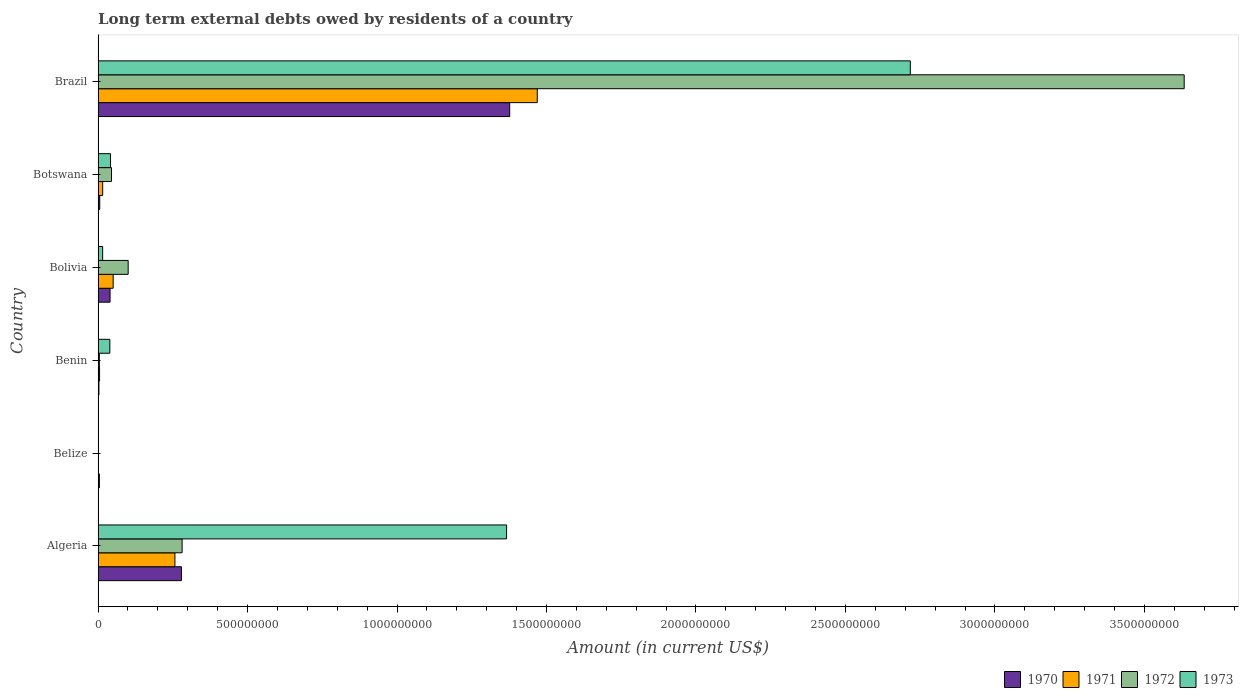Are the number of bars per tick equal to the number of legend labels?
Provide a short and direct response. No. How many bars are there on the 1st tick from the top?
Offer a terse response. 4. How many bars are there on the 3rd tick from the bottom?
Your answer should be very brief. 4. What is the label of the 2nd group of bars from the top?
Keep it short and to the point. Botswana. What is the amount of long-term external debts owed by residents in 1973 in Algeria?
Your response must be concise. 1.37e+09. Across all countries, what is the maximum amount of long-term external debts owed by residents in 1973?
Your answer should be very brief. 2.72e+09. Across all countries, what is the minimum amount of long-term external debts owed by residents in 1970?
Your answer should be very brief. 2.87e+06. What is the total amount of long-term external debts owed by residents in 1971 in the graph?
Provide a succinct answer. 1.80e+09. What is the difference between the amount of long-term external debts owed by residents in 1970 in Algeria and that in Benin?
Give a very brief answer. 2.76e+08. What is the difference between the amount of long-term external debts owed by residents in 1972 in Brazil and the amount of long-term external debts owed by residents in 1971 in Belize?
Your response must be concise. 3.63e+09. What is the average amount of long-term external debts owed by residents in 1972 per country?
Provide a short and direct response. 6.77e+08. What is the difference between the amount of long-term external debts owed by residents in 1972 and amount of long-term external debts owed by residents in 1973 in Botswana?
Offer a very short reply. 3.47e+06. In how many countries, is the amount of long-term external debts owed by residents in 1971 greater than 1600000000 US$?
Provide a short and direct response. 0. What is the ratio of the amount of long-term external debts owed by residents in 1970 in Botswana to that in Brazil?
Your answer should be very brief. 0. What is the difference between the highest and the second highest amount of long-term external debts owed by residents in 1973?
Keep it short and to the point. 1.35e+09. What is the difference between the highest and the lowest amount of long-term external debts owed by residents in 1973?
Give a very brief answer. 2.72e+09. In how many countries, is the amount of long-term external debts owed by residents in 1972 greater than the average amount of long-term external debts owed by residents in 1972 taken over all countries?
Give a very brief answer. 1. Is it the case that in every country, the sum of the amount of long-term external debts owed by residents in 1971 and amount of long-term external debts owed by residents in 1973 is greater than the sum of amount of long-term external debts owed by residents in 1972 and amount of long-term external debts owed by residents in 1970?
Provide a succinct answer. No. What is the difference between two consecutive major ticks on the X-axis?
Your answer should be very brief. 5.00e+08. Are the values on the major ticks of X-axis written in scientific E-notation?
Offer a very short reply. No. Does the graph contain any zero values?
Your response must be concise. Yes. Where does the legend appear in the graph?
Provide a short and direct response. Bottom right. How many legend labels are there?
Your answer should be very brief. 4. How are the legend labels stacked?
Your answer should be very brief. Horizontal. What is the title of the graph?
Ensure brevity in your answer.  Long term external debts owed by residents of a country. Does "1987" appear as one of the legend labels in the graph?
Your answer should be very brief. No. What is the label or title of the X-axis?
Give a very brief answer. Amount (in current US$). What is the label or title of the Y-axis?
Your answer should be very brief. Country. What is the Amount (in current US$) of 1970 in Algeria?
Offer a very short reply. 2.79e+08. What is the Amount (in current US$) of 1971 in Algeria?
Keep it short and to the point. 2.57e+08. What is the Amount (in current US$) in 1972 in Algeria?
Your answer should be compact. 2.81e+08. What is the Amount (in current US$) of 1973 in Algeria?
Your response must be concise. 1.37e+09. What is the Amount (in current US$) in 1970 in Belize?
Keep it short and to the point. 4.30e+06. What is the Amount (in current US$) in 1973 in Belize?
Offer a terse response. 0. What is the Amount (in current US$) in 1970 in Benin?
Your answer should be compact. 2.87e+06. What is the Amount (in current US$) of 1971 in Benin?
Provide a short and direct response. 4.99e+06. What is the Amount (in current US$) of 1972 in Benin?
Keep it short and to the point. 4.28e+06. What is the Amount (in current US$) of 1973 in Benin?
Ensure brevity in your answer.  3.93e+07. What is the Amount (in current US$) of 1970 in Bolivia?
Provide a short and direct response. 4.01e+07. What is the Amount (in current US$) of 1971 in Bolivia?
Your response must be concise. 5.04e+07. What is the Amount (in current US$) in 1972 in Bolivia?
Keep it short and to the point. 1.01e+08. What is the Amount (in current US$) in 1973 in Bolivia?
Make the answer very short. 1.53e+07. What is the Amount (in current US$) of 1970 in Botswana?
Ensure brevity in your answer.  5.57e+06. What is the Amount (in current US$) in 1971 in Botswana?
Provide a short and direct response. 1.54e+07. What is the Amount (in current US$) in 1972 in Botswana?
Provide a succinct answer. 4.50e+07. What is the Amount (in current US$) of 1973 in Botswana?
Keep it short and to the point. 4.15e+07. What is the Amount (in current US$) of 1970 in Brazil?
Keep it short and to the point. 1.38e+09. What is the Amount (in current US$) in 1971 in Brazil?
Offer a very short reply. 1.47e+09. What is the Amount (in current US$) of 1972 in Brazil?
Keep it short and to the point. 3.63e+09. What is the Amount (in current US$) in 1973 in Brazil?
Ensure brevity in your answer.  2.72e+09. Across all countries, what is the maximum Amount (in current US$) of 1970?
Give a very brief answer. 1.38e+09. Across all countries, what is the maximum Amount (in current US$) of 1971?
Give a very brief answer. 1.47e+09. Across all countries, what is the maximum Amount (in current US$) in 1972?
Keep it short and to the point. 3.63e+09. Across all countries, what is the maximum Amount (in current US$) in 1973?
Give a very brief answer. 2.72e+09. Across all countries, what is the minimum Amount (in current US$) in 1970?
Your answer should be compact. 2.87e+06. Across all countries, what is the minimum Amount (in current US$) in 1972?
Your answer should be compact. 0. What is the total Amount (in current US$) in 1970 in the graph?
Provide a short and direct response. 1.71e+09. What is the total Amount (in current US$) in 1971 in the graph?
Provide a succinct answer. 1.80e+09. What is the total Amount (in current US$) of 1972 in the graph?
Your answer should be very brief. 4.06e+09. What is the total Amount (in current US$) of 1973 in the graph?
Provide a short and direct response. 4.18e+09. What is the difference between the Amount (in current US$) of 1970 in Algeria and that in Belize?
Your answer should be very brief. 2.74e+08. What is the difference between the Amount (in current US$) of 1970 in Algeria and that in Benin?
Provide a short and direct response. 2.76e+08. What is the difference between the Amount (in current US$) in 1971 in Algeria and that in Benin?
Ensure brevity in your answer.  2.52e+08. What is the difference between the Amount (in current US$) in 1972 in Algeria and that in Benin?
Offer a very short reply. 2.77e+08. What is the difference between the Amount (in current US$) of 1973 in Algeria and that in Benin?
Make the answer very short. 1.33e+09. What is the difference between the Amount (in current US$) in 1970 in Algeria and that in Bolivia?
Your answer should be compact. 2.39e+08. What is the difference between the Amount (in current US$) of 1971 in Algeria and that in Bolivia?
Make the answer very short. 2.07e+08. What is the difference between the Amount (in current US$) in 1972 in Algeria and that in Bolivia?
Offer a terse response. 1.80e+08. What is the difference between the Amount (in current US$) of 1973 in Algeria and that in Bolivia?
Give a very brief answer. 1.35e+09. What is the difference between the Amount (in current US$) of 1970 in Algeria and that in Botswana?
Your response must be concise. 2.73e+08. What is the difference between the Amount (in current US$) of 1971 in Algeria and that in Botswana?
Your answer should be very brief. 2.42e+08. What is the difference between the Amount (in current US$) of 1972 in Algeria and that in Botswana?
Ensure brevity in your answer.  2.36e+08. What is the difference between the Amount (in current US$) of 1973 in Algeria and that in Botswana?
Give a very brief answer. 1.32e+09. What is the difference between the Amount (in current US$) in 1970 in Algeria and that in Brazil?
Provide a short and direct response. -1.10e+09. What is the difference between the Amount (in current US$) of 1971 in Algeria and that in Brazil?
Keep it short and to the point. -1.21e+09. What is the difference between the Amount (in current US$) in 1972 in Algeria and that in Brazil?
Offer a very short reply. -3.35e+09. What is the difference between the Amount (in current US$) of 1973 in Algeria and that in Brazil?
Keep it short and to the point. -1.35e+09. What is the difference between the Amount (in current US$) of 1970 in Belize and that in Benin?
Your response must be concise. 1.43e+06. What is the difference between the Amount (in current US$) in 1970 in Belize and that in Bolivia?
Your answer should be very brief. -3.58e+07. What is the difference between the Amount (in current US$) of 1970 in Belize and that in Botswana?
Provide a short and direct response. -1.27e+06. What is the difference between the Amount (in current US$) of 1970 in Belize and that in Brazil?
Your answer should be very brief. -1.37e+09. What is the difference between the Amount (in current US$) in 1970 in Benin and that in Bolivia?
Your answer should be very brief. -3.72e+07. What is the difference between the Amount (in current US$) in 1971 in Benin and that in Bolivia?
Offer a terse response. -4.54e+07. What is the difference between the Amount (in current US$) in 1972 in Benin and that in Bolivia?
Make the answer very short. -9.64e+07. What is the difference between the Amount (in current US$) in 1973 in Benin and that in Bolivia?
Your answer should be very brief. 2.40e+07. What is the difference between the Amount (in current US$) in 1970 in Benin and that in Botswana?
Your answer should be very brief. -2.70e+06. What is the difference between the Amount (in current US$) in 1971 in Benin and that in Botswana?
Provide a short and direct response. -1.04e+07. What is the difference between the Amount (in current US$) in 1972 in Benin and that in Botswana?
Your response must be concise. -4.07e+07. What is the difference between the Amount (in current US$) in 1973 in Benin and that in Botswana?
Ensure brevity in your answer.  -2.15e+06. What is the difference between the Amount (in current US$) in 1970 in Benin and that in Brazil?
Your answer should be compact. -1.37e+09. What is the difference between the Amount (in current US$) of 1971 in Benin and that in Brazil?
Provide a short and direct response. -1.46e+09. What is the difference between the Amount (in current US$) of 1972 in Benin and that in Brazil?
Your answer should be very brief. -3.63e+09. What is the difference between the Amount (in current US$) in 1973 in Benin and that in Brazil?
Your response must be concise. -2.68e+09. What is the difference between the Amount (in current US$) of 1970 in Bolivia and that in Botswana?
Make the answer very short. 3.45e+07. What is the difference between the Amount (in current US$) of 1971 in Bolivia and that in Botswana?
Your response must be concise. 3.50e+07. What is the difference between the Amount (in current US$) in 1972 in Bolivia and that in Botswana?
Ensure brevity in your answer.  5.57e+07. What is the difference between the Amount (in current US$) in 1973 in Bolivia and that in Botswana?
Provide a succinct answer. -2.62e+07. What is the difference between the Amount (in current US$) of 1970 in Bolivia and that in Brazil?
Make the answer very short. -1.34e+09. What is the difference between the Amount (in current US$) of 1971 in Bolivia and that in Brazil?
Offer a terse response. -1.42e+09. What is the difference between the Amount (in current US$) in 1972 in Bolivia and that in Brazil?
Give a very brief answer. -3.53e+09. What is the difference between the Amount (in current US$) of 1973 in Bolivia and that in Brazil?
Your answer should be compact. -2.70e+09. What is the difference between the Amount (in current US$) of 1970 in Botswana and that in Brazil?
Give a very brief answer. -1.37e+09. What is the difference between the Amount (in current US$) of 1971 in Botswana and that in Brazil?
Provide a short and direct response. -1.45e+09. What is the difference between the Amount (in current US$) of 1972 in Botswana and that in Brazil?
Your response must be concise. -3.59e+09. What is the difference between the Amount (in current US$) of 1973 in Botswana and that in Brazil?
Provide a succinct answer. -2.68e+09. What is the difference between the Amount (in current US$) of 1970 in Algeria and the Amount (in current US$) of 1971 in Benin?
Keep it short and to the point. 2.74e+08. What is the difference between the Amount (in current US$) of 1970 in Algeria and the Amount (in current US$) of 1972 in Benin?
Provide a succinct answer. 2.75e+08. What is the difference between the Amount (in current US$) of 1970 in Algeria and the Amount (in current US$) of 1973 in Benin?
Ensure brevity in your answer.  2.39e+08. What is the difference between the Amount (in current US$) of 1971 in Algeria and the Amount (in current US$) of 1972 in Benin?
Offer a very short reply. 2.53e+08. What is the difference between the Amount (in current US$) of 1971 in Algeria and the Amount (in current US$) of 1973 in Benin?
Offer a very short reply. 2.18e+08. What is the difference between the Amount (in current US$) of 1972 in Algeria and the Amount (in current US$) of 1973 in Benin?
Give a very brief answer. 2.42e+08. What is the difference between the Amount (in current US$) in 1970 in Algeria and the Amount (in current US$) in 1971 in Bolivia?
Your response must be concise. 2.28e+08. What is the difference between the Amount (in current US$) in 1970 in Algeria and the Amount (in current US$) in 1972 in Bolivia?
Offer a very short reply. 1.78e+08. What is the difference between the Amount (in current US$) of 1970 in Algeria and the Amount (in current US$) of 1973 in Bolivia?
Provide a short and direct response. 2.63e+08. What is the difference between the Amount (in current US$) of 1971 in Algeria and the Amount (in current US$) of 1972 in Bolivia?
Offer a terse response. 1.56e+08. What is the difference between the Amount (in current US$) of 1971 in Algeria and the Amount (in current US$) of 1973 in Bolivia?
Offer a very short reply. 2.42e+08. What is the difference between the Amount (in current US$) of 1972 in Algeria and the Amount (in current US$) of 1973 in Bolivia?
Make the answer very short. 2.66e+08. What is the difference between the Amount (in current US$) of 1970 in Algeria and the Amount (in current US$) of 1971 in Botswana?
Provide a succinct answer. 2.63e+08. What is the difference between the Amount (in current US$) of 1970 in Algeria and the Amount (in current US$) of 1972 in Botswana?
Your response must be concise. 2.34e+08. What is the difference between the Amount (in current US$) in 1970 in Algeria and the Amount (in current US$) in 1973 in Botswana?
Your answer should be compact. 2.37e+08. What is the difference between the Amount (in current US$) in 1971 in Algeria and the Amount (in current US$) in 1972 in Botswana?
Ensure brevity in your answer.  2.12e+08. What is the difference between the Amount (in current US$) in 1971 in Algeria and the Amount (in current US$) in 1973 in Botswana?
Ensure brevity in your answer.  2.16e+08. What is the difference between the Amount (in current US$) in 1972 in Algeria and the Amount (in current US$) in 1973 in Botswana?
Offer a terse response. 2.40e+08. What is the difference between the Amount (in current US$) of 1970 in Algeria and the Amount (in current US$) of 1971 in Brazil?
Offer a very short reply. -1.19e+09. What is the difference between the Amount (in current US$) in 1970 in Algeria and the Amount (in current US$) in 1972 in Brazil?
Your response must be concise. -3.35e+09. What is the difference between the Amount (in current US$) of 1970 in Algeria and the Amount (in current US$) of 1973 in Brazil?
Offer a terse response. -2.44e+09. What is the difference between the Amount (in current US$) in 1971 in Algeria and the Amount (in current US$) in 1972 in Brazil?
Your answer should be compact. -3.38e+09. What is the difference between the Amount (in current US$) of 1971 in Algeria and the Amount (in current US$) of 1973 in Brazil?
Offer a very short reply. -2.46e+09. What is the difference between the Amount (in current US$) of 1972 in Algeria and the Amount (in current US$) of 1973 in Brazil?
Make the answer very short. -2.44e+09. What is the difference between the Amount (in current US$) in 1970 in Belize and the Amount (in current US$) in 1971 in Benin?
Provide a succinct answer. -6.88e+05. What is the difference between the Amount (in current US$) in 1970 in Belize and the Amount (in current US$) in 1972 in Benin?
Offer a very short reply. 2.40e+04. What is the difference between the Amount (in current US$) of 1970 in Belize and the Amount (in current US$) of 1973 in Benin?
Ensure brevity in your answer.  -3.50e+07. What is the difference between the Amount (in current US$) of 1970 in Belize and the Amount (in current US$) of 1971 in Bolivia?
Give a very brief answer. -4.61e+07. What is the difference between the Amount (in current US$) in 1970 in Belize and the Amount (in current US$) in 1972 in Bolivia?
Your response must be concise. -9.63e+07. What is the difference between the Amount (in current US$) of 1970 in Belize and the Amount (in current US$) of 1973 in Bolivia?
Your answer should be compact. -1.10e+07. What is the difference between the Amount (in current US$) of 1970 in Belize and the Amount (in current US$) of 1971 in Botswana?
Make the answer very short. -1.11e+07. What is the difference between the Amount (in current US$) of 1970 in Belize and the Amount (in current US$) of 1972 in Botswana?
Make the answer very short. -4.07e+07. What is the difference between the Amount (in current US$) of 1970 in Belize and the Amount (in current US$) of 1973 in Botswana?
Offer a terse response. -3.72e+07. What is the difference between the Amount (in current US$) of 1970 in Belize and the Amount (in current US$) of 1971 in Brazil?
Your answer should be compact. -1.46e+09. What is the difference between the Amount (in current US$) in 1970 in Belize and the Amount (in current US$) in 1972 in Brazil?
Offer a very short reply. -3.63e+09. What is the difference between the Amount (in current US$) of 1970 in Belize and the Amount (in current US$) of 1973 in Brazil?
Your answer should be compact. -2.71e+09. What is the difference between the Amount (in current US$) of 1970 in Benin and the Amount (in current US$) of 1971 in Bolivia?
Keep it short and to the point. -4.75e+07. What is the difference between the Amount (in current US$) in 1970 in Benin and the Amount (in current US$) in 1972 in Bolivia?
Provide a short and direct response. -9.78e+07. What is the difference between the Amount (in current US$) of 1970 in Benin and the Amount (in current US$) of 1973 in Bolivia?
Your answer should be very brief. -1.24e+07. What is the difference between the Amount (in current US$) of 1971 in Benin and the Amount (in current US$) of 1972 in Bolivia?
Your response must be concise. -9.57e+07. What is the difference between the Amount (in current US$) in 1971 in Benin and the Amount (in current US$) in 1973 in Bolivia?
Offer a very short reply. -1.03e+07. What is the difference between the Amount (in current US$) in 1972 in Benin and the Amount (in current US$) in 1973 in Bolivia?
Ensure brevity in your answer.  -1.10e+07. What is the difference between the Amount (in current US$) in 1970 in Benin and the Amount (in current US$) in 1971 in Botswana?
Make the answer very short. -1.25e+07. What is the difference between the Amount (in current US$) of 1970 in Benin and the Amount (in current US$) of 1972 in Botswana?
Your answer should be very brief. -4.21e+07. What is the difference between the Amount (in current US$) in 1970 in Benin and the Amount (in current US$) in 1973 in Botswana?
Provide a short and direct response. -3.86e+07. What is the difference between the Amount (in current US$) in 1971 in Benin and the Amount (in current US$) in 1972 in Botswana?
Your answer should be compact. -4.00e+07. What is the difference between the Amount (in current US$) in 1971 in Benin and the Amount (in current US$) in 1973 in Botswana?
Your answer should be compact. -3.65e+07. What is the difference between the Amount (in current US$) of 1972 in Benin and the Amount (in current US$) of 1973 in Botswana?
Offer a very short reply. -3.72e+07. What is the difference between the Amount (in current US$) in 1970 in Benin and the Amount (in current US$) in 1971 in Brazil?
Ensure brevity in your answer.  -1.47e+09. What is the difference between the Amount (in current US$) in 1970 in Benin and the Amount (in current US$) in 1972 in Brazil?
Your answer should be compact. -3.63e+09. What is the difference between the Amount (in current US$) in 1970 in Benin and the Amount (in current US$) in 1973 in Brazil?
Provide a succinct answer. -2.71e+09. What is the difference between the Amount (in current US$) of 1971 in Benin and the Amount (in current US$) of 1972 in Brazil?
Provide a succinct answer. -3.63e+09. What is the difference between the Amount (in current US$) in 1971 in Benin and the Amount (in current US$) in 1973 in Brazil?
Offer a very short reply. -2.71e+09. What is the difference between the Amount (in current US$) of 1972 in Benin and the Amount (in current US$) of 1973 in Brazil?
Provide a succinct answer. -2.71e+09. What is the difference between the Amount (in current US$) in 1970 in Bolivia and the Amount (in current US$) in 1971 in Botswana?
Offer a very short reply. 2.47e+07. What is the difference between the Amount (in current US$) of 1970 in Bolivia and the Amount (in current US$) of 1972 in Botswana?
Make the answer very short. -4.88e+06. What is the difference between the Amount (in current US$) in 1970 in Bolivia and the Amount (in current US$) in 1973 in Botswana?
Keep it short and to the point. -1.40e+06. What is the difference between the Amount (in current US$) in 1971 in Bolivia and the Amount (in current US$) in 1972 in Botswana?
Offer a very short reply. 5.46e+06. What is the difference between the Amount (in current US$) in 1971 in Bolivia and the Amount (in current US$) in 1973 in Botswana?
Provide a short and direct response. 8.94e+06. What is the difference between the Amount (in current US$) in 1972 in Bolivia and the Amount (in current US$) in 1973 in Botswana?
Provide a short and direct response. 5.92e+07. What is the difference between the Amount (in current US$) in 1970 in Bolivia and the Amount (in current US$) in 1971 in Brazil?
Provide a short and direct response. -1.43e+09. What is the difference between the Amount (in current US$) in 1970 in Bolivia and the Amount (in current US$) in 1972 in Brazil?
Your answer should be compact. -3.59e+09. What is the difference between the Amount (in current US$) in 1970 in Bolivia and the Amount (in current US$) in 1973 in Brazil?
Your answer should be very brief. -2.68e+09. What is the difference between the Amount (in current US$) in 1971 in Bolivia and the Amount (in current US$) in 1972 in Brazil?
Your response must be concise. -3.58e+09. What is the difference between the Amount (in current US$) of 1971 in Bolivia and the Amount (in current US$) of 1973 in Brazil?
Offer a very short reply. -2.67e+09. What is the difference between the Amount (in current US$) in 1972 in Bolivia and the Amount (in current US$) in 1973 in Brazil?
Give a very brief answer. -2.62e+09. What is the difference between the Amount (in current US$) in 1970 in Botswana and the Amount (in current US$) in 1971 in Brazil?
Offer a very short reply. -1.46e+09. What is the difference between the Amount (in current US$) in 1970 in Botswana and the Amount (in current US$) in 1972 in Brazil?
Offer a very short reply. -3.63e+09. What is the difference between the Amount (in current US$) of 1970 in Botswana and the Amount (in current US$) of 1973 in Brazil?
Provide a short and direct response. -2.71e+09. What is the difference between the Amount (in current US$) in 1971 in Botswana and the Amount (in current US$) in 1972 in Brazil?
Keep it short and to the point. -3.62e+09. What is the difference between the Amount (in current US$) of 1971 in Botswana and the Amount (in current US$) of 1973 in Brazil?
Make the answer very short. -2.70e+09. What is the difference between the Amount (in current US$) of 1972 in Botswana and the Amount (in current US$) of 1973 in Brazil?
Your answer should be compact. -2.67e+09. What is the average Amount (in current US$) in 1970 per country?
Give a very brief answer. 2.85e+08. What is the average Amount (in current US$) in 1971 per country?
Offer a very short reply. 2.99e+08. What is the average Amount (in current US$) of 1972 per country?
Your answer should be compact. 6.77e+08. What is the average Amount (in current US$) of 1973 per country?
Offer a very short reply. 6.97e+08. What is the difference between the Amount (in current US$) of 1970 and Amount (in current US$) of 1971 in Algeria?
Provide a succinct answer. 2.18e+07. What is the difference between the Amount (in current US$) in 1970 and Amount (in current US$) in 1972 in Algeria?
Your response must be concise. -2.27e+06. What is the difference between the Amount (in current US$) of 1970 and Amount (in current US$) of 1973 in Algeria?
Offer a very short reply. -1.09e+09. What is the difference between the Amount (in current US$) of 1971 and Amount (in current US$) of 1972 in Algeria?
Provide a short and direct response. -2.41e+07. What is the difference between the Amount (in current US$) in 1971 and Amount (in current US$) in 1973 in Algeria?
Provide a succinct answer. -1.11e+09. What is the difference between the Amount (in current US$) of 1972 and Amount (in current US$) of 1973 in Algeria?
Make the answer very short. -1.09e+09. What is the difference between the Amount (in current US$) of 1970 and Amount (in current US$) of 1971 in Benin?
Keep it short and to the point. -2.12e+06. What is the difference between the Amount (in current US$) of 1970 and Amount (in current US$) of 1972 in Benin?
Ensure brevity in your answer.  -1.41e+06. What is the difference between the Amount (in current US$) in 1970 and Amount (in current US$) in 1973 in Benin?
Offer a terse response. -3.65e+07. What is the difference between the Amount (in current US$) in 1971 and Amount (in current US$) in 1972 in Benin?
Ensure brevity in your answer.  7.12e+05. What is the difference between the Amount (in current US$) in 1971 and Amount (in current US$) in 1973 in Benin?
Provide a short and direct response. -3.43e+07. What is the difference between the Amount (in current US$) in 1972 and Amount (in current US$) in 1973 in Benin?
Provide a short and direct response. -3.51e+07. What is the difference between the Amount (in current US$) in 1970 and Amount (in current US$) in 1971 in Bolivia?
Offer a very short reply. -1.03e+07. What is the difference between the Amount (in current US$) of 1970 and Amount (in current US$) of 1972 in Bolivia?
Give a very brief answer. -6.06e+07. What is the difference between the Amount (in current US$) of 1970 and Amount (in current US$) of 1973 in Bolivia?
Offer a very short reply. 2.48e+07. What is the difference between the Amount (in current US$) in 1971 and Amount (in current US$) in 1972 in Bolivia?
Offer a terse response. -5.02e+07. What is the difference between the Amount (in current US$) in 1971 and Amount (in current US$) in 1973 in Bolivia?
Your answer should be very brief. 3.51e+07. What is the difference between the Amount (in current US$) of 1972 and Amount (in current US$) of 1973 in Bolivia?
Your answer should be very brief. 8.53e+07. What is the difference between the Amount (in current US$) of 1970 and Amount (in current US$) of 1971 in Botswana?
Ensure brevity in your answer.  -9.82e+06. What is the difference between the Amount (in current US$) of 1970 and Amount (in current US$) of 1972 in Botswana?
Give a very brief answer. -3.94e+07. What is the difference between the Amount (in current US$) of 1970 and Amount (in current US$) of 1973 in Botswana?
Ensure brevity in your answer.  -3.59e+07. What is the difference between the Amount (in current US$) of 1971 and Amount (in current US$) of 1972 in Botswana?
Give a very brief answer. -2.96e+07. What is the difference between the Amount (in current US$) of 1971 and Amount (in current US$) of 1973 in Botswana?
Your answer should be compact. -2.61e+07. What is the difference between the Amount (in current US$) of 1972 and Amount (in current US$) of 1973 in Botswana?
Provide a short and direct response. 3.47e+06. What is the difference between the Amount (in current US$) in 1970 and Amount (in current US$) in 1971 in Brazil?
Give a very brief answer. -9.22e+07. What is the difference between the Amount (in current US$) in 1970 and Amount (in current US$) in 1972 in Brazil?
Offer a very short reply. -2.26e+09. What is the difference between the Amount (in current US$) of 1970 and Amount (in current US$) of 1973 in Brazil?
Make the answer very short. -1.34e+09. What is the difference between the Amount (in current US$) in 1971 and Amount (in current US$) in 1972 in Brazil?
Offer a very short reply. -2.16e+09. What is the difference between the Amount (in current US$) of 1971 and Amount (in current US$) of 1973 in Brazil?
Your answer should be very brief. -1.25e+09. What is the difference between the Amount (in current US$) of 1972 and Amount (in current US$) of 1973 in Brazil?
Ensure brevity in your answer.  9.16e+08. What is the ratio of the Amount (in current US$) of 1970 in Algeria to that in Belize?
Your response must be concise. 64.82. What is the ratio of the Amount (in current US$) in 1970 in Algeria to that in Benin?
Provide a short and direct response. 97.24. What is the ratio of the Amount (in current US$) of 1971 in Algeria to that in Benin?
Your answer should be very brief. 51.51. What is the ratio of the Amount (in current US$) in 1972 in Algeria to that in Benin?
Keep it short and to the point. 65.71. What is the ratio of the Amount (in current US$) in 1973 in Algeria to that in Benin?
Give a very brief answer. 34.74. What is the ratio of the Amount (in current US$) of 1970 in Algeria to that in Bolivia?
Your answer should be very brief. 6.96. What is the ratio of the Amount (in current US$) of 1971 in Algeria to that in Bolivia?
Your answer should be very brief. 5.1. What is the ratio of the Amount (in current US$) in 1972 in Algeria to that in Bolivia?
Keep it short and to the point. 2.79. What is the ratio of the Amount (in current US$) in 1973 in Algeria to that in Bolivia?
Give a very brief answer. 89.32. What is the ratio of the Amount (in current US$) of 1970 in Algeria to that in Botswana?
Make the answer very short. 50.08. What is the ratio of the Amount (in current US$) of 1971 in Algeria to that in Botswana?
Offer a very short reply. 16.7. What is the ratio of the Amount (in current US$) of 1972 in Algeria to that in Botswana?
Your response must be concise. 6.25. What is the ratio of the Amount (in current US$) in 1973 in Algeria to that in Botswana?
Make the answer very short. 32.94. What is the ratio of the Amount (in current US$) of 1970 in Algeria to that in Brazil?
Ensure brevity in your answer.  0.2. What is the ratio of the Amount (in current US$) of 1971 in Algeria to that in Brazil?
Your response must be concise. 0.17. What is the ratio of the Amount (in current US$) of 1972 in Algeria to that in Brazil?
Keep it short and to the point. 0.08. What is the ratio of the Amount (in current US$) in 1973 in Algeria to that in Brazil?
Offer a terse response. 0.5. What is the ratio of the Amount (in current US$) of 1970 in Belize to that in Benin?
Give a very brief answer. 1.5. What is the ratio of the Amount (in current US$) in 1970 in Belize to that in Bolivia?
Provide a succinct answer. 0.11. What is the ratio of the Amount (in current US$) in 1970 in Belize to that in Botswana?
Offer a terse response. 0.77. What is the ratio of the Amount (in current US$) in 1970 in Belize to that in Brazil?
Your response must be concise. 0. What is the ratio of the Amount (in current US$) of 1970 in Benin to that in Bolivia?
Keep it short and to the point. 0.07. What is the ratio of the Amount (in current US$) in 1971 in Benin to that in Bolivia?
Your response must be concise. 0.1. What is the ratio of the Amount (in current US$) of 1972 in Benin to that in Bolivia?
Keep it short and to the point. 0.04. What is the ratio of the Amount (in current US$) in 1973 in Benin to that in Bolivia?
Give a very brief answer. 2.57. What is the ratio of the Amount (in current US$) of 1970 in Benin to that in Botswana?
Your answer should be very brief. 0.52. What is the ratio of the Amount (in current US$) in 1971 in Benin to that in Botswana?
Ensure brevity in your answer.  0.32. What is the ratio of the Amount (in current US$) in 1972 in Benin to that in Botswana?
Offer a very short reply. 0.1. What is the ratio of the Amount (in current US$) of 1973 in Benin to that in Botswana?
Your answer should be very brief. 0.95. What is the ratio of the Amount (in current US$) of 1970 in Benin to that in Brazil?
Provide a short and direct response. 0. What is the ratio of the Amount (in current US$) of 1971 in Benin to that in Brazil?
Provide a short and direct response. 0. What is the ratio of the Amount (in current US$) of 1972 in Benin to that in Brazil?
Provide a succinct answer. 0. What is the ratio of the Amount (in current US$) in 1973 in Benin to that in Brazil?
Your answer should be very brief. 0.01. What is the ratio of the Amount (in current US$) in 1970 in Bolivia to that in Botswana?
Give a very brief answer. 7.2. What is the ratio of the Amount (in current US$) in 1971 in Bolivia to that in Botswana?
Your answer should be compact. 3.28. What is the ratio of the Amount (in current US$) of 1972 in Bolivia to that in Botswana?
Your answer should be compact. 2.24. What is the ratio of the Amount (in current US$) of 1973 in Bolivia to that in Botswana?
Provide a short and direct response. 0.37. What is the ratio of the Amount (in current US$) in 1970 in Bolivia to that in Brazil?
Give a very brief answer. 0.03. What is the ratio of the Amount (in current US$) in 1971 in Bolivia to that in Brazil?
Keep it short and to the point. 0.03. What is the ratio of the Amount (in current US$) in 1972 in Bolivia to that in Brazil?
Your answer should be very brief. 0.03. What is the ratio of the Amount (in current US$) of 1973 in Bolivia to that in Brazil?
Provide a succinct answer. 0.01. What is the ratio of the Amount (in current US$) in 1970 in Botswana to that in Brazil?
Offer a terse response. 0. What is the ratio of the Amount (in current US$) in 1971 in Botswana to that in Brazil?
Give a very brief answer. 0.01. What is the ratio of the Amount (in current US$) of 1972 in Botswana to that in Brazil?
Your answer should be very brief. 0.01. What is the ratio of the Amount (in current US$) in 1973 in Botswana to that in Brazil?
Offer a terse response. 0.02. What is the difference between the highest and the second highest Amount (in current US$) in 1970?
Give a very brief answer. 1.10e+09. What is the difference between the highest and the second highest Amount (in current US$) of 1971?
Your answer should be very brief. 1.21e+09. What is the difference between the highest and the second highest Amount (in current US$) of 1972?
Your answer should be compact. 3.35e+09. What is the difference between the highest and the second highest Amount (in current US$) of 1973?
Provide a short and direct response. 1.35e+09. What is the difference between the highest and the lowest Amount (in current US$) of 1970?
Offer a very short reply. 1.37e+09. What is the difference between the highest and the lowest Amount (in current US$) of 1971?
Ensure brevity in your answer.  1.47e+09. What is the difference between the highest and the lowest Amount (in current US$) of 1972?
Your response must be concise. 3.63e+09. What is the difference between the highest and the lowest Amount (in current US$) of 1973?
Ensure brevity in your answer.  2.72e+09. 